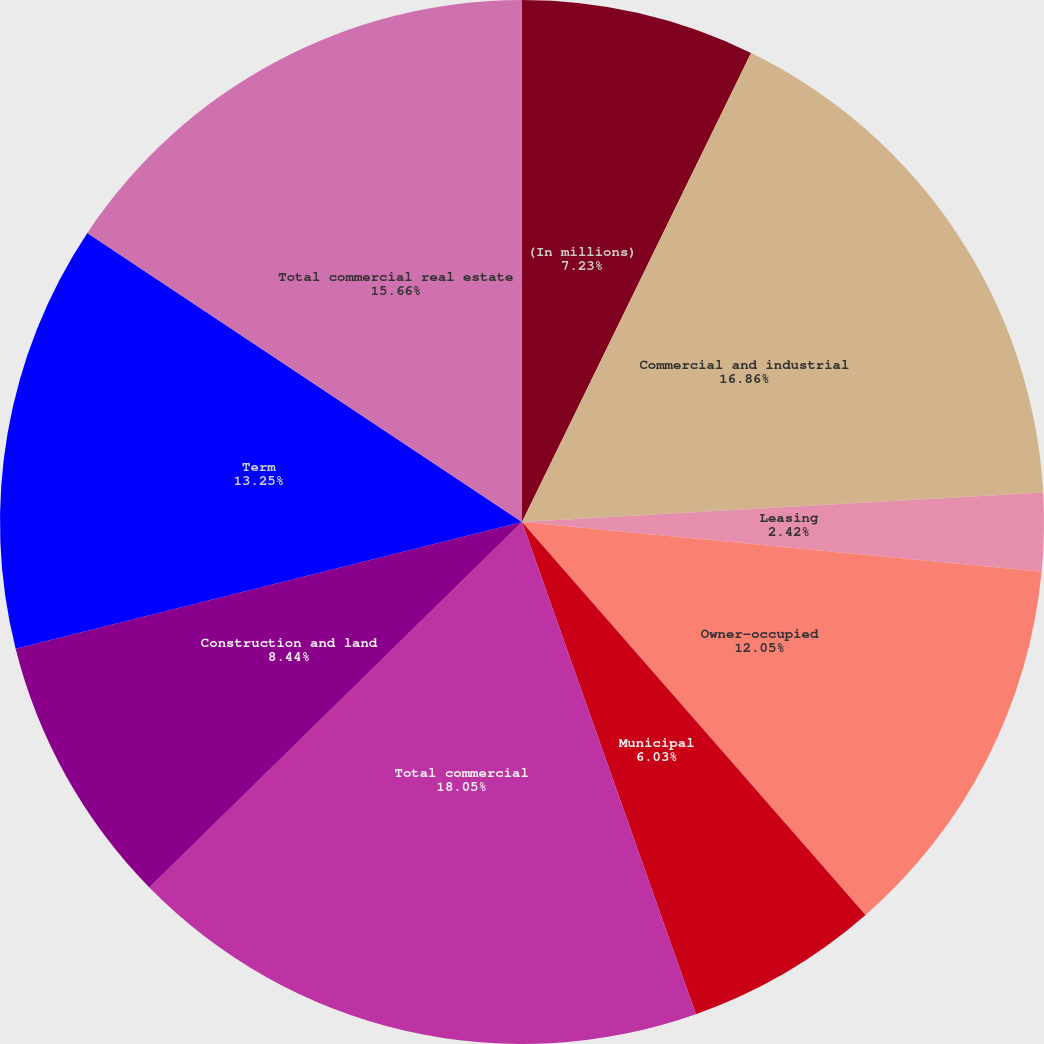Convert chart to OTSL. <chart><loc_0><loc_0><loc_500><loc_500><pie_chart><fcel>(In millions)<fcel>Loans held for sale<fcel>Commercial and industrial<fcel>Leasing<fcel>Owner-occupied<fcel>Municipal<fcel>Total commercial<fcel>Construction and land<fcel>Term<fcel>Total commercial real estate<nl><fcel>7.23%<fcel>0.01%<fcel>16.86%<fcel>2.42%<fcel>12.05%<fcel>6.03%<fcel>18.06%<fcel>8.44%<fcel>13.25%<fcel>15.66%<nl></chart> 